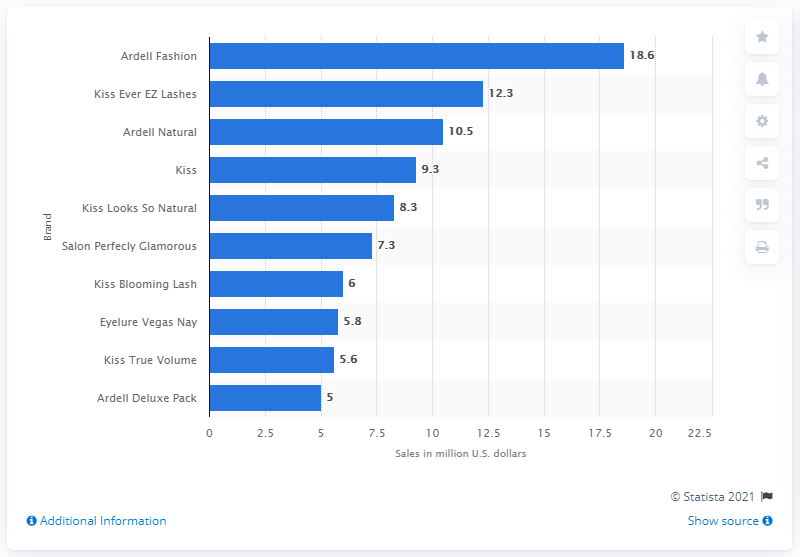Identify some key points in this picture. In 2017, Ardell Fashion generated $18.6 million in sales. 